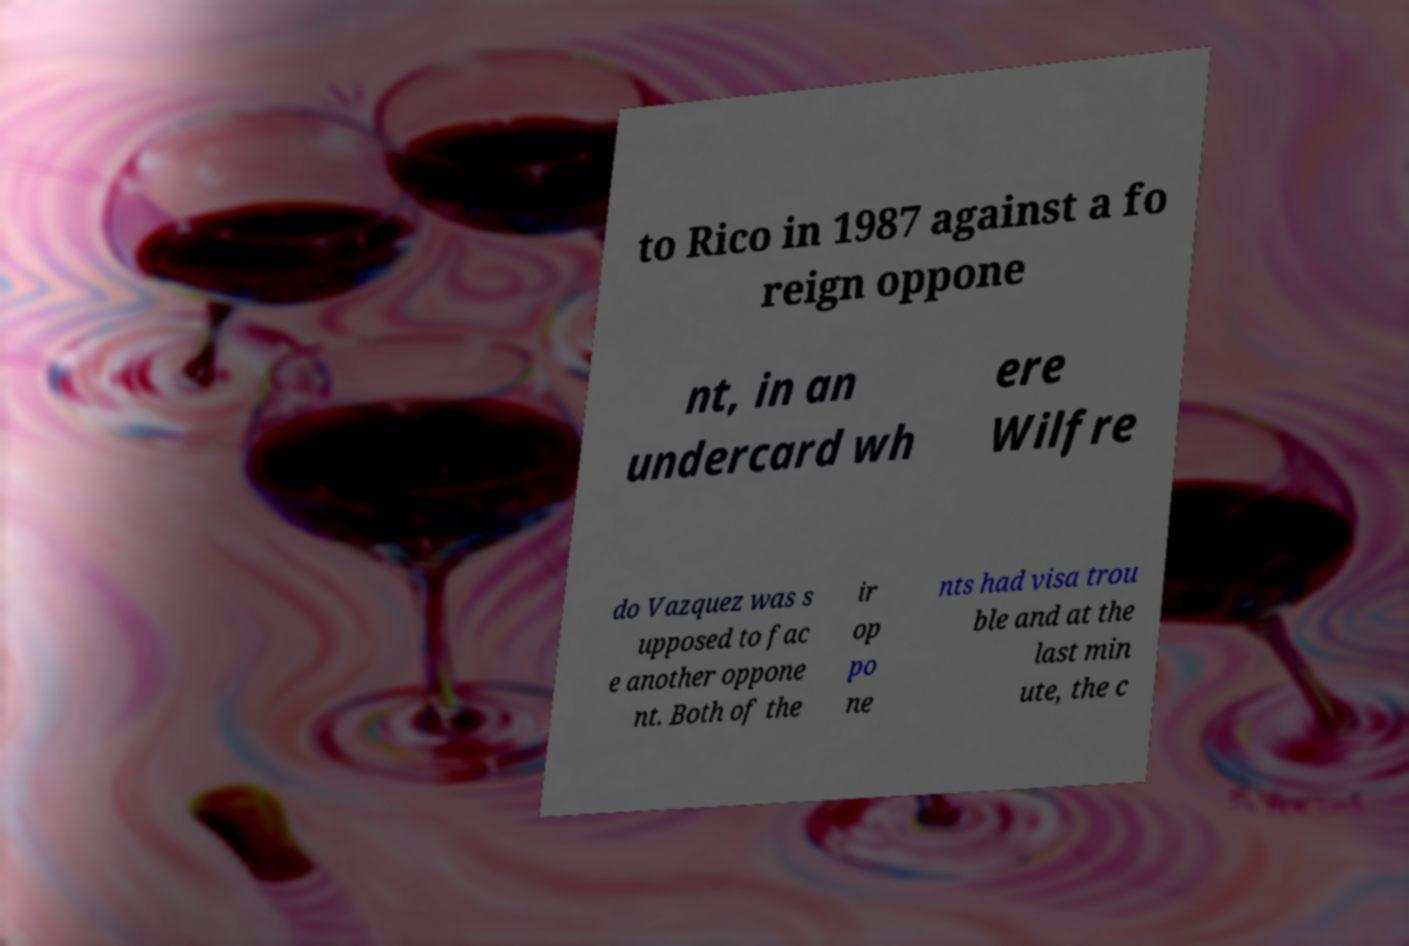Could you assist in decoding the text presented in this image and type it out clearly? to Rico in 1987 against a fo reign oppone nt, in an undercard wh ere Wilfre do Vazquez was s upposed to fac e another oppone nt. Both of the ir op po ne nts had visa trou ble and at the last min ute, the c 